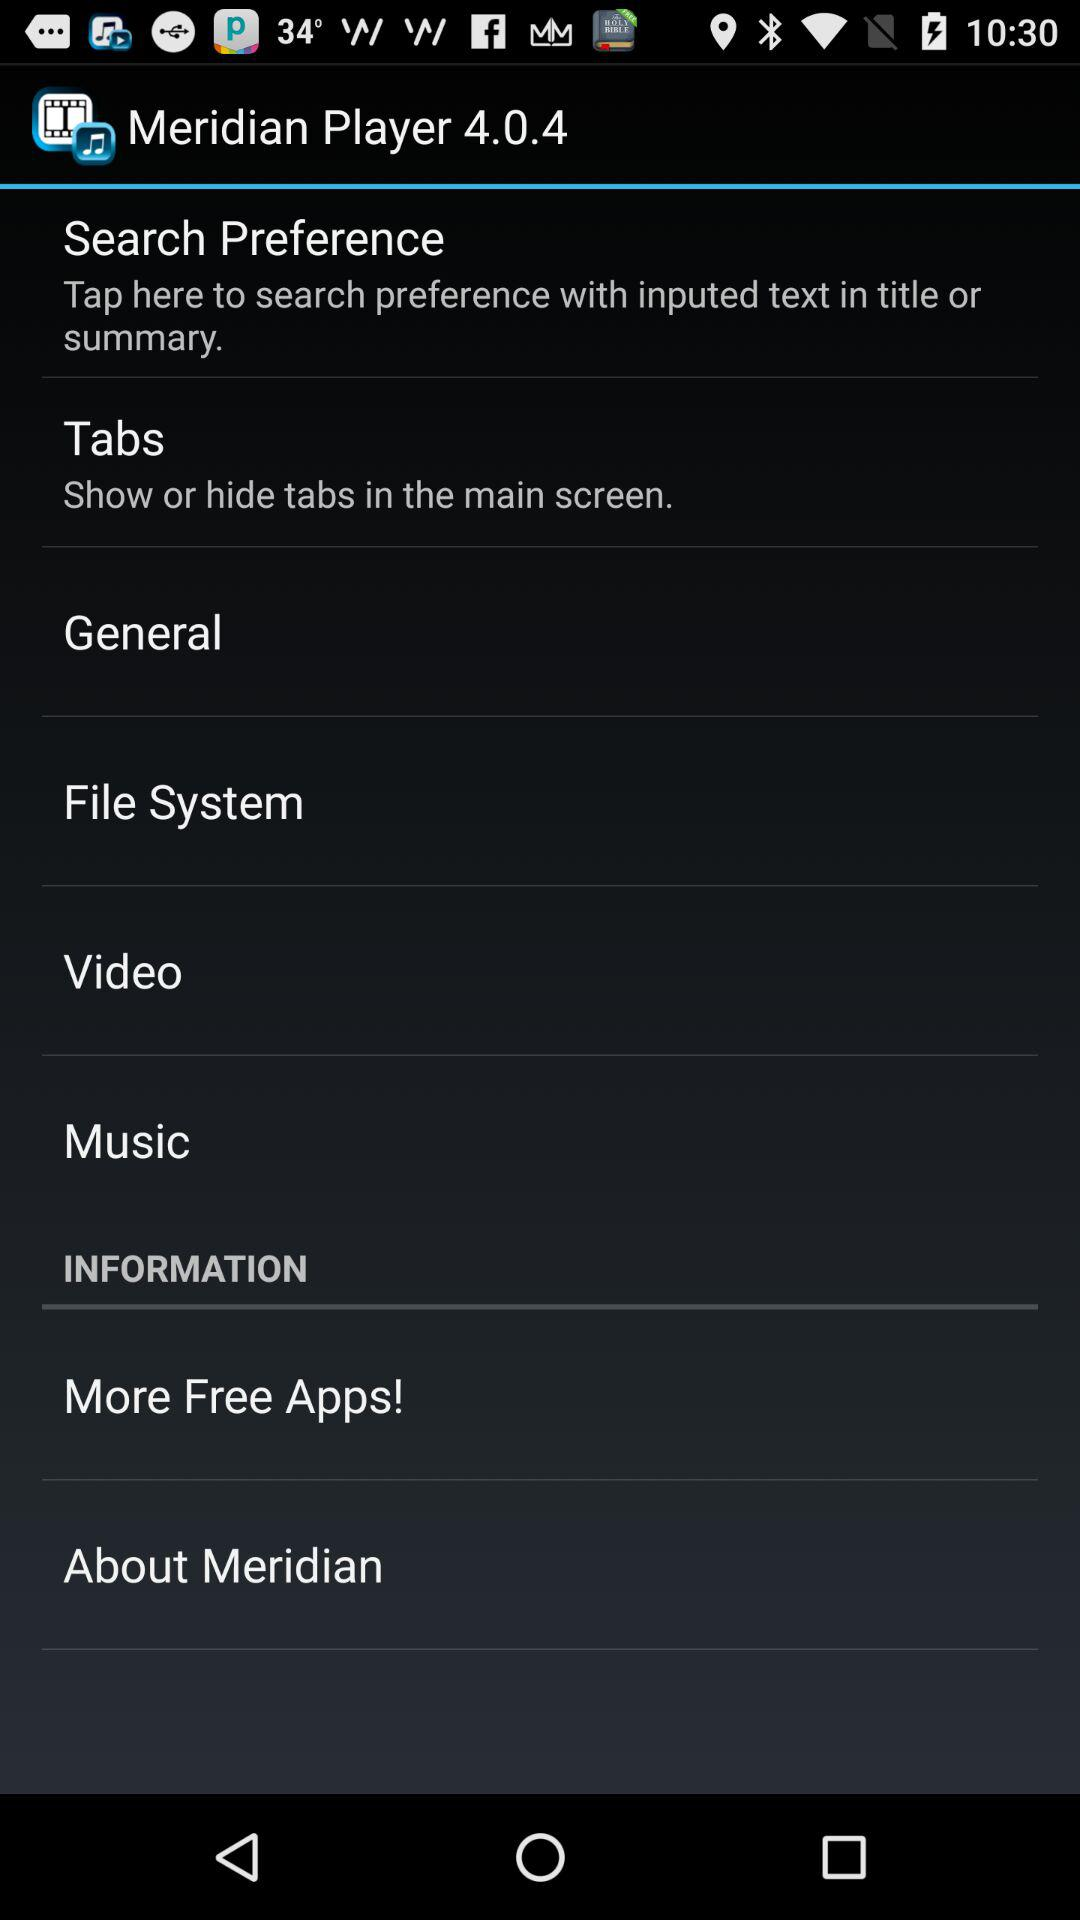What is the version? The version is 4.0.4. 